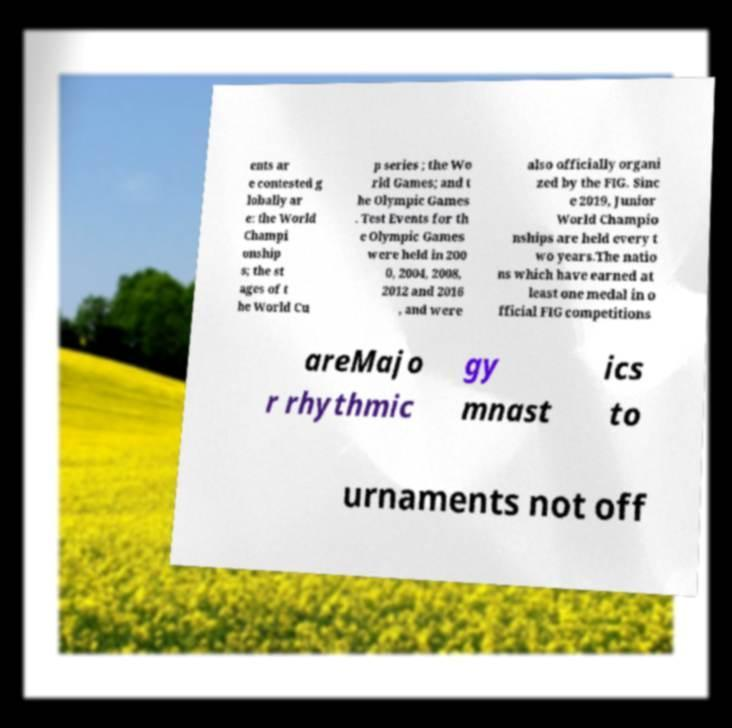Can you accurately transcribe the text from the provided image for me? ents ar e contested g lobally ar e: the World Champi onship s; the st ages of t he World Cu p series ; the Wo rld Games; and t he Olympic Games . Test Events for th e Olympic Games were held in 200 0, 2004, 2008, 2012 and 2016 , and were also officially organi zed by the FIG. Sinc e 2019, Junior World Champio nships are held every t wo years.The natio ns which have earned at least one medal in o fficial FIG competitions areMajo r rhythmic gy mnast ics to urnaments not off 